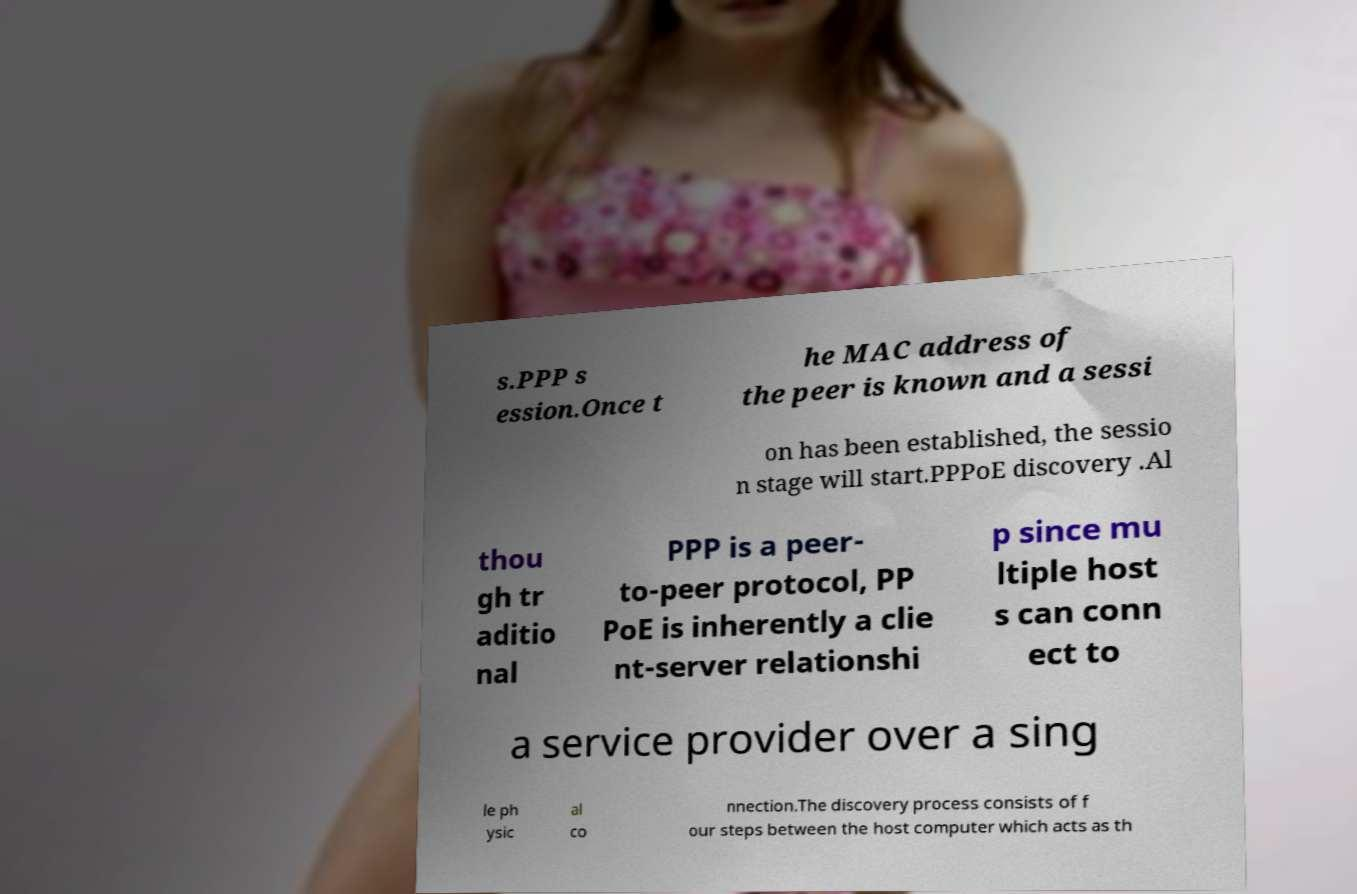Please identify and transcribe the text found in this image. s.PPP s ession.Once t he MAC address of the peer is known and a sessi on has been established, the sessio n stage will start.PPPoE discovery .Al thou gh tr aditio nal PPP is a peer- to-peer protocol, PP PoE is inherently a clie nt-server relationshi p since mu ltiple host s can conn ect to a service provider over a sing le ph ysic al co nnection.The discovery process consists of f our steps between the host computer which acts as th 